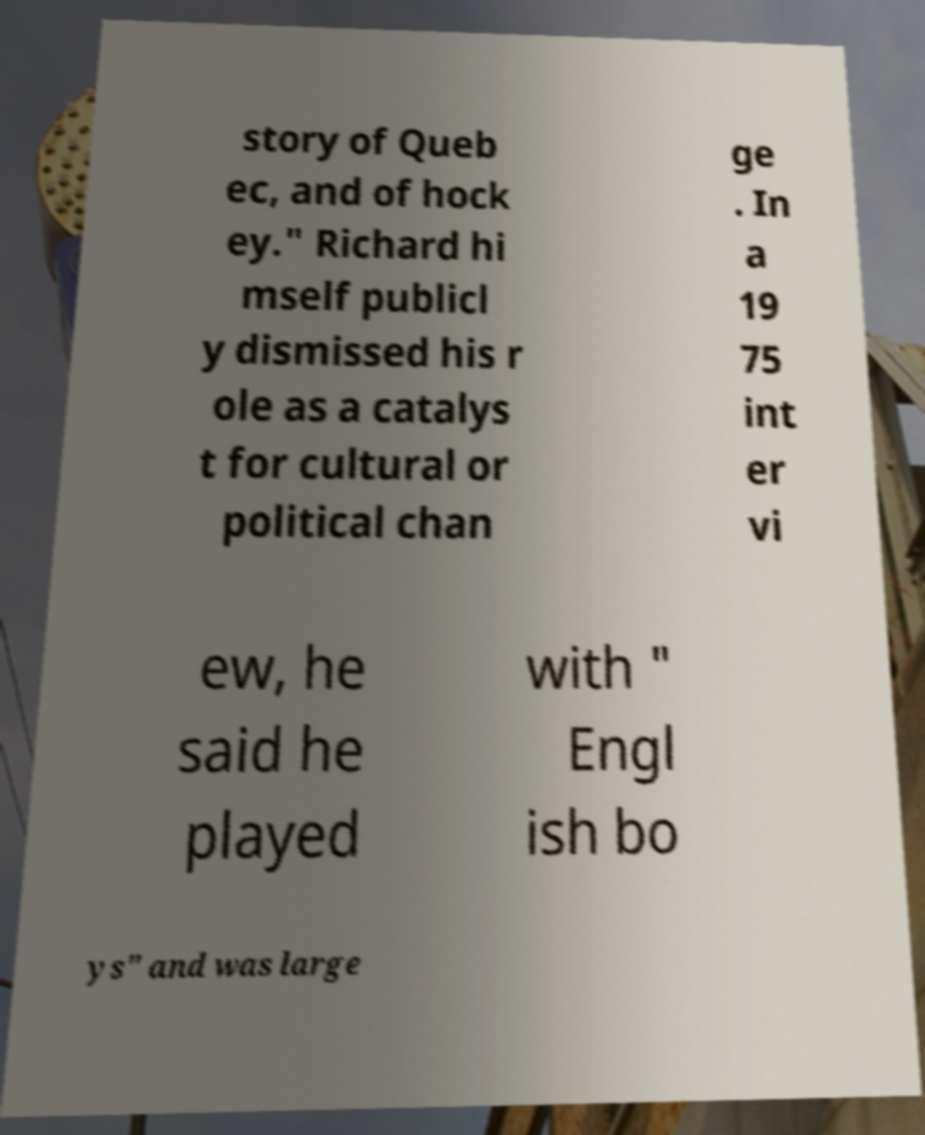Could you assist in decoding the text presented in this image and type it out clearly? story of Queb ec, and of hock ey." Richard hi mself publicl y dismissed his r ole as a catalys t for cultural or political chan ge . In a 19 75 int er vi ew, he said he played with " Engl ish bo ys" and was large 